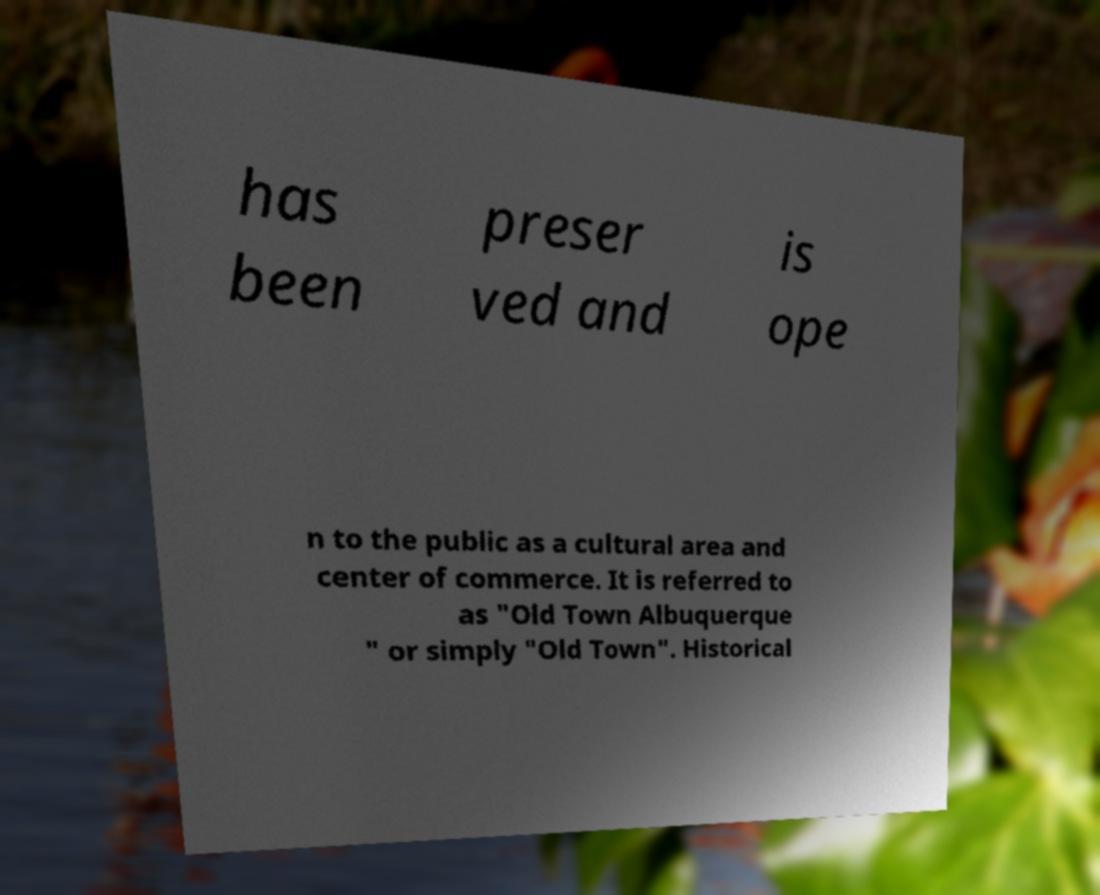Could you extract and type out the text from this image? has been preser ved and is ope n to the public as a cultural area and center of commerce. It is referred to as "Old Town Albuquerque " or simply "Old Town". Historical 